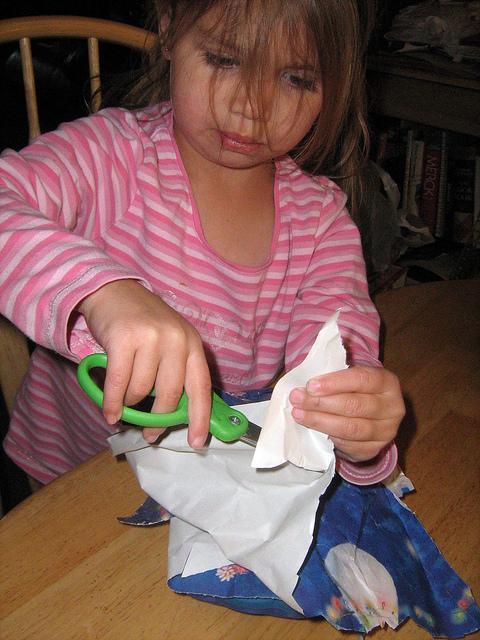How many languages do you think this child can write?
Give a very brief answer. 1. How many birds are standing in the water?
Give a very brief answer. 0. 